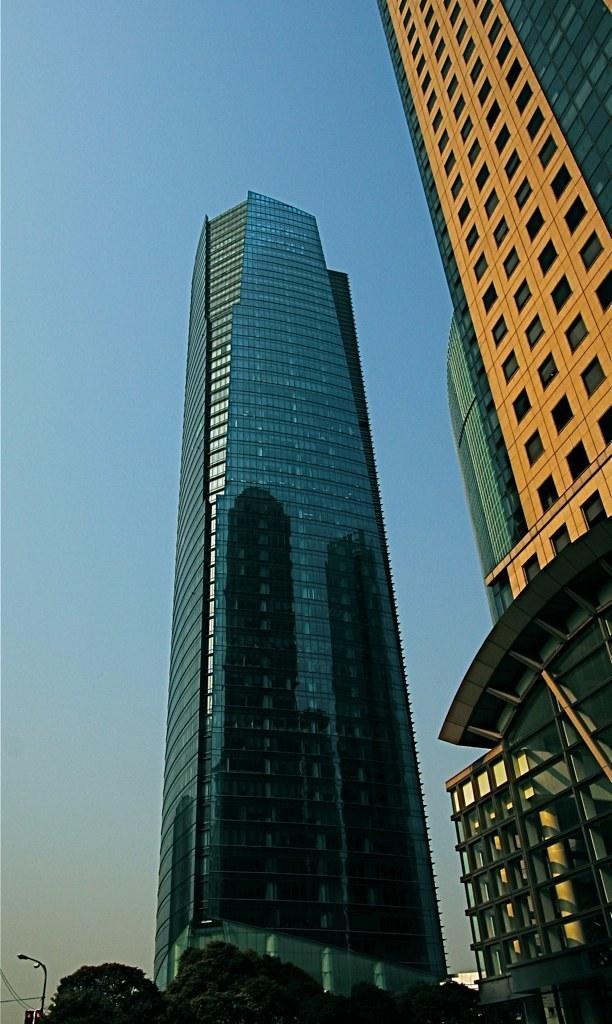Please provide a concise description of this image. In the center of the image buildings are present. At the bottom of the image we can see trees, electric light pole, wires are there. In the background of the image sky is there. 